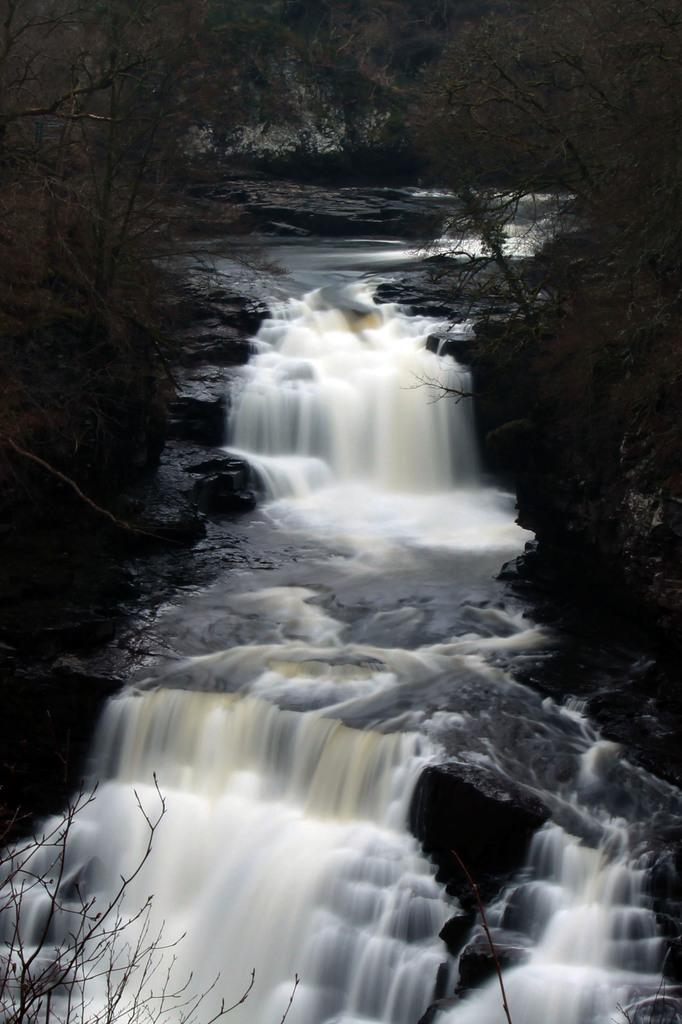What natural feature is the main subject of the image? There is a waterfall in the image. What is the condition of the trees near the waterfall? There are dried trees in the image. Can you hear the police laughing while holding a rifle in the image? There is no police or rifle present in the image, and therefore no such activity can be observed. 